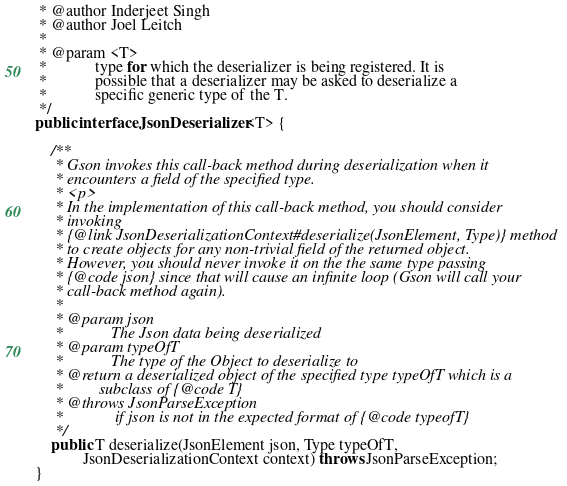<code> <loc_0><loc_0><loc_500><loc_500><_Java_> * @author Inderjeet Singh
 * @author Joel Leitch
 *
 * @param <T>
 *            type for which the deserializer is being registered. It is
 *            possible that a deserializer may be asked to deserialize a
 *            specific generic type of the T.
 */
public interface JsonDeserializer<T> {

	/**
	 * Gson invokes this call-back method during deserialization when it
	 * encounters a field of the specified type.
	 * <p>
	 * In the implementation of this call-back method, you should consider
	 * invoking
	 * {@link JsonDeserializationContext#deserialize(JsonElement, Type)} method
	 * to create objects for any non-trivial field of the returned object.
	 * However, you should never invoke it on the the same type passing
	 * {@code json} since that will cause an infinite loop (Gson will call your
	 * call-back method again).
	 *
	 * @param json
	 *            The Json data being deserialized
	 * @param typeOfT
	 *            The type of the Object to deserialize to
	 * @return a deserialized object of the specified type typeOfT which is a
	 *         subclass of {@code T}
	 * @throws JsonParseException
	 *             if json is not in the expected format of {@code typeofT}
	 */
	public T deserialize(JsonElement json, Type typeOfT,
			JsonDeserializationContext context) throws JsonParseException;
}
</code> 